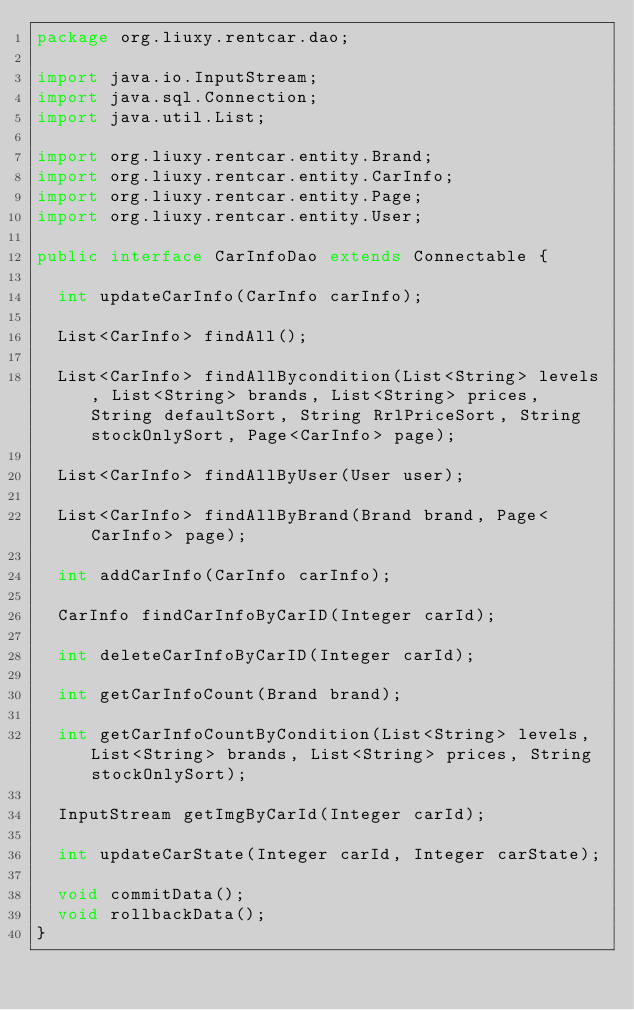Convert code to text. <code><loc_0><loc_0><loc_500><loc_500><_Java_>package org.liuxy.rentcar.dao;

import java.io.InputStream;
import java.sql.Connection;
import java.util.List;

import org.liuxy.rentcar.entity.Brand;
import org.liuxy.rentcar.entity.CarInfo;
import org.liuxy.rentcar.entity.Page;
import org.liuxy.rentcar.entity.User;

public interface CarInfoDao extends Connectable {

	int updateCarInfo(CarInfo carInfo);
	
	List<CarInfo> findAll();
	
	List<CarInfo> findAllBycondition(List<String> levels, List<String> brands, List<String> prices, String defaultSort, String RrlPriceSort, String stockOnlySort, Page<CarInfo> page);
	
	List<CarInfo> findAllByUser(User user);
	
	List<CarInfo> findAllByBrand(Brand brand, Page<CarInfo> page);
	
	int addCarInfo(CarInfo carInfo);
	
	CarInfo findCarInfoByCarID(Integer carId);
	
	int deleteCarInfoByCarID(Integer carId);
	
	int getCarInfoCount(Brand brand);
	
	int getCarInfoCountByCondition(List<String> levels, List<String> brands, List<String> prices, String stockOnlySort);
	
	InputStream getImgByCarId(Integer carId);
	
	int updateCarState(Integer carId, Integer carState);
	
	void commitData();
	void rollbackData();
}
</code> 